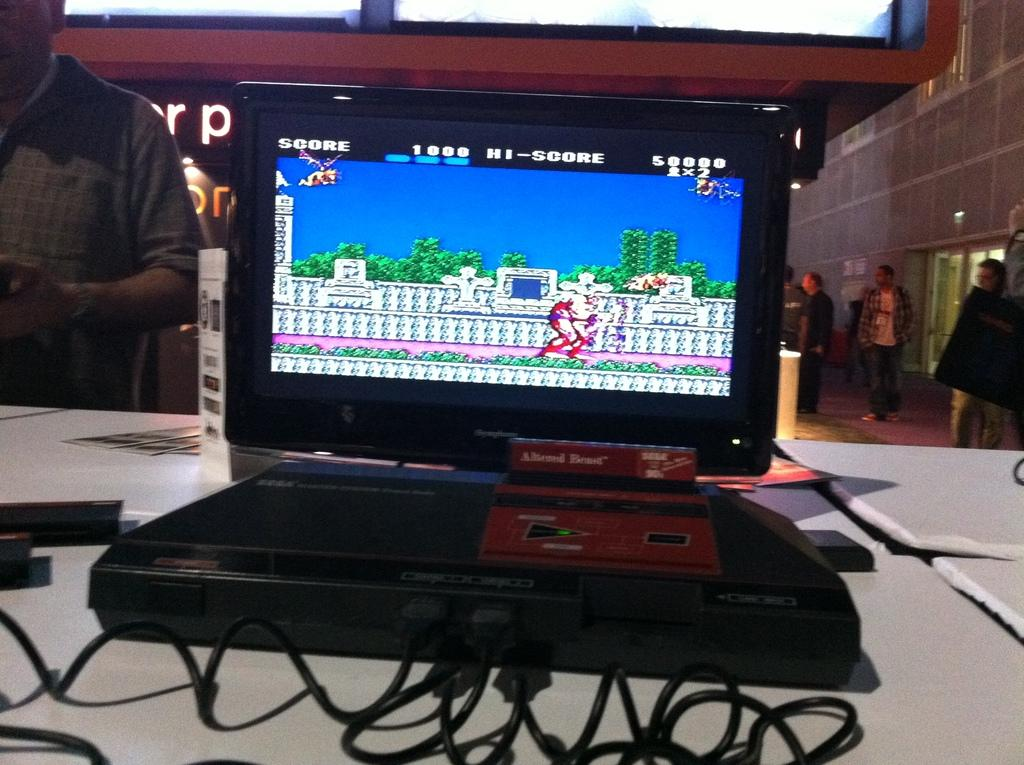<image>
Describe the image concisely. A laptop displays a video game with a score of 1000. 